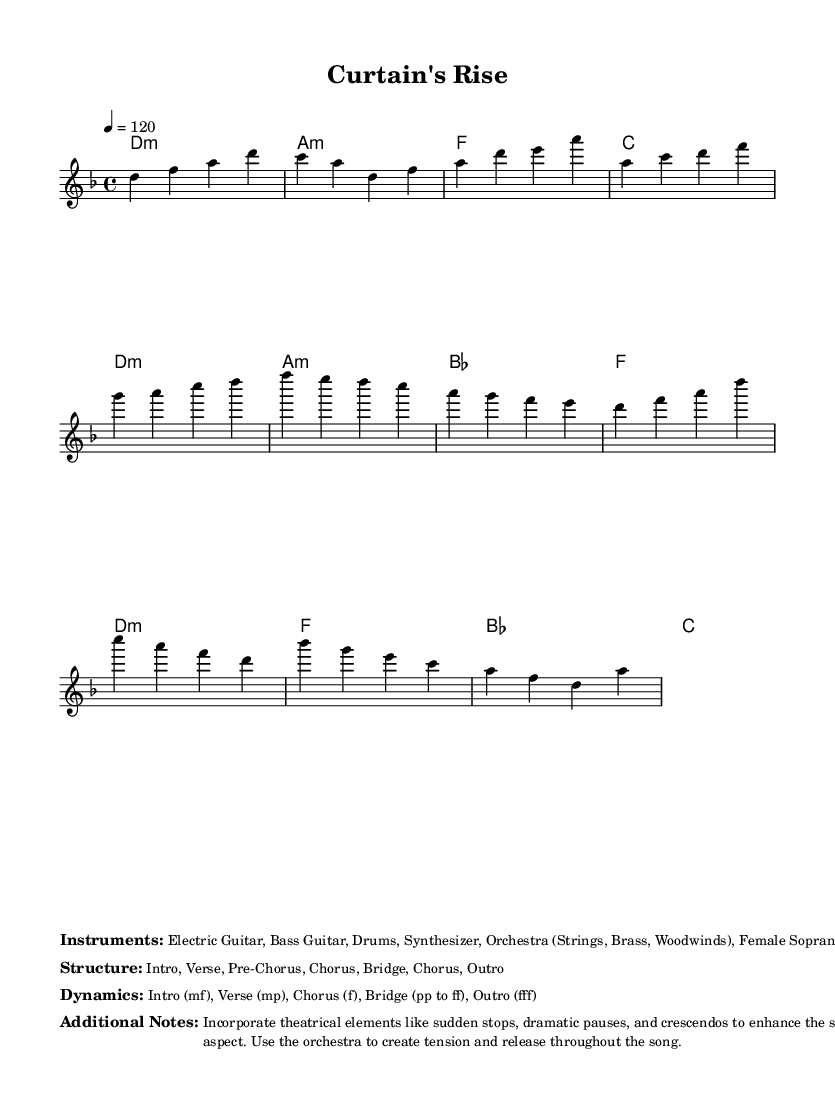What is the key signature of this music? The key signature is D minor, indicated by the presence of one flat (B♭) in the key signature.
Answer: D minor What is the time signature of this music? The time signature is 4/4, which means there are four beats per measure, and each quarter note gets one beat.
Answer: 4/4 What is the tempo marking of this piece? The tempo marking is indicated as 120 beats per minute, which is shown in the score as "4 = 120".
Answer: 120 What are the primary instruments used in this piece? The instruments listed include Electric Guitar, Bass Guitar, Drums, Synthesizer, and Orchestra components like Strings, Brass, Woodwinds, along with Female Soprano Vocals.
Answer: Electric Guitar, Bass Guitar, Drums, Synthesizer, Orchestra (Strings, Brass, Woodwinds), Female Soprano Vocals How many sections does this music structure have? The structure includes seven sections as listed: Intro, Verse, Pre-Chorus, Chorus, Bridge, Chorus, Outro.
Answer: Seven What dynamics are indicated for the Chorus section? The dynamics for the Chorus section are Forte (f), which indicates a loud volume that contrasts with the softer dynamics of the previous sections.
Answer: f Why is orchestration emphasized in this piece? Orchestration is emphasized to enhance the dramatic storytelling aspect, creating tension and release, as indicated in the additional notes which encourage the use of sudden stops and crescendos.
Answer: To enhance storytelling 